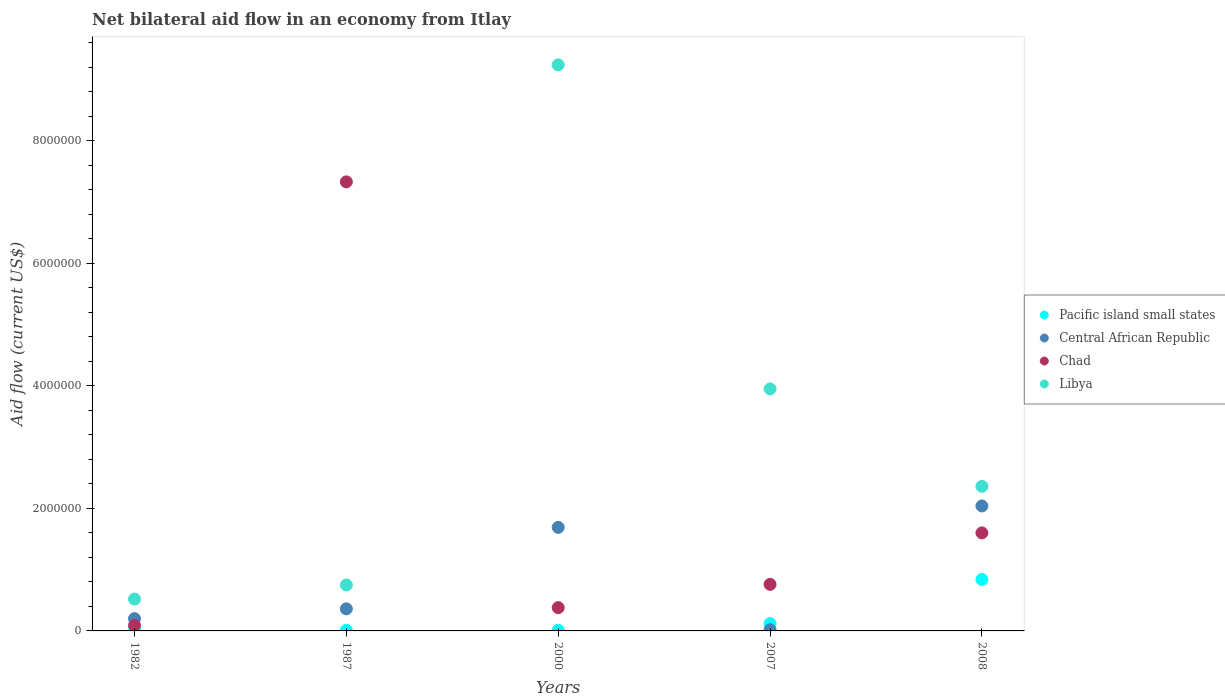Across all years, what is the maximum net bilateral aid flow in Pacific island small states?
Provide a short and direct response. 8.40e+05. In which year was the net bilateral aid flow in Central African Republic minimum?
Offer a terse response. 2007. What is the total net bilateral aid flow in Chad in the graph?
Keep it short and to the point. 1.02e+07. What is the difference between the net bilateral aid flow in Central African Republic in 1982 and that in 2000?
Your answer should be very brief. -1.49e+06. What is the average net bilateral aid flow in Chad per year?
Ensure brevity in your answer.  2.03e+06. In the year 2007, what is the difference between the net bilateral aid flow in Pacific island small states and net bilateral aid flow in Central African Republic?
Your response must be concise. 1.00e+05. What is the ratio of the net bilateral aid flow in Chad in 1982 to that in 2007?
Keep it short and to the point. 0.12. What is the difference between the highest and the second highest net bilateral aid flow in Pacific island small states?
Offer a terse response. 7.20e+05. What is the difference between the highest and the lowest net bilateral aid flow in Libya?
Your answer should be very brief. 8.72e+06. Is it the case that in every year, the sum of the net bilateral aid flow in Libya and net bilateral aid flow in Pacific island small states  is greater than the sum of net bilateral aid flow in Chad and net bilateral aid flow in Central African Republic?
Ensure brevity in your answer.  Yes. Is it the case that in every year, the sum of the net bilateral aid flow in Central African Republic and net bilateral aid flow in Chad  is greater than the net bilateral aid flow in Libya?
Provide a short and direct response. No. Is the net bilateral aid flow in Pacific island small states strictly less than the net bilateral aid flow in Libya over the years?
Offer a very short reply. Yes. Are the values on the major ticks of Y-axis written in scientific E-notation?
Your response must be concise. No. What is the title of the graph?
Make the answer very short. Net bilateral aid flow in an economy from Itlay. Does "Jamaica" appear as one of the legend labels in the graph?
Provide a succinct answer. No. What is the label or title of the X-axis?
Provide a short and direct response. Years. What is the Aid flow (current US$) in Libya in 1982?
Offer a very short reply. 5.20e+05. What is the Aid flow (current US$) of Central African Republic in 1987?
Keep it short and to the point. 3.60e+05. What is the Aid flow (current US$) of Chad in 1987?
Your answer should be compact. 7.33e+06. What is the Aid flow (current US$) of Libya in 1987?
Offer a very short reply. 7.50e+05. What is the Aid flow (current US$) in Pacific island small states in 2000?
Give a very brief answer. 10000. What is the Aid flow (current US$) of Central African Republic in 2000?
Make the answer very short. 1.69e+06. What is the Aid flow (current US$) in Libya in 2000?
Your response must be concise. 9.24e+06. What is the Aid flow (current US$) in Central African Republic in 2007?
Ensure brevity in your answer.  2.00e+04. What is the Aid flow (current US$) of Chad in 2007?
Your response must be concise. 7.60e+05. What is the Aid flow (current US$) in Libya in 2007?
Offer a very short reply. 3.95e+06. What is the Aid flow (current US$) in Pacific island small states in 2008?
Ensure brevity in your answer.  8.40e+05. What is the Aid flow (current US$) of Central African Republic in 2008?
Ensure brevity in your answer.  2.04e+06. What is the Aid flow (current US$) in Chad in 2008?
Your answer should be compact. 1.60e+06. What is the Aid flow (current US$) in Libya in 2008?
Make the answer very short. 2.36e+06. Across all years, what is the maximum Aid flow (current US$) in Pacific island small states?
Your answer should be compact. 8.40e+05. Across all years, what is the maximum Aid flow (current US$) of Central African Republic?
Offer a very short reply. 2.04e+06. Across all years, what is the maximum Aid flow (current US$) of Chad?
Keep it short and to the point. 7.33e+06. Across all years, what is the maximum Aid flow (current US$) of Libya?
Ensure brevity in your answer.  9.24e+06. Across all years, what is the minimum Aid flow (current US$) of Central African Republic?
Make the answer very short. 2.00e+04. Across all years, what is the minimum Aid flow (current US$) of Libya?
Provide a succinct answer. 5.20e+05. What is the total Aid flow (current US$) of Pacific island small states in the graph?
Provide a succinct answer. 1.02e+06. What is the total Aid flow (current US$) of Central African Republic in the graph?
Offer a very short reply. 4.31e+06. What is the total Aid flow (current US$) in Chad in the graph?
Your response must be concise. 1.02e+07. What is the total Aid flow (current US$) in Libya in the graph?
Ensure brevity in your answer.  1.68e+07. What is the difference between the Aid flow (current US$) of Pacific island small states in 1982 and that in 1987?
Offer a very short reply. 3.00e+04. What is the difference between the Aid flow (current US$) of Chad in 1982 and that in 1987?
Your response must be concise. -7.24e+06. What is the difference between the Aid flow (current US$) in Libya in 1982 and that in 1987?
Give a very brief answer. -2.30e+05. What is the difference between the Aid flow (current US$) of Central African Republic in 1982 and that in 2000?
Offer a very short reply. -1.49e+06. What is the difference between the Aid flow (current US$) of Chad in 1982 and that in 2000?
Ensure brevity in your answer.  -2.90e+05. What is the difference between the Aid flow (current US$) of Libya in 1982 and that in 2000?
Give a very brief answer. -8.72e+06. What is the difference between the Aid flow (current US$) in Pacific island small states in 1982 and that in 2007?
Offer a terse response. -8.00e+04. What is the difference between the Aid flow (current US$) in Central African Republic in 1982 and that in 2007?
Ensure brevity in your answer.  1.80e+05. What is the difference between the Aid flow (current US$) in Chad in 1982 and that in 2007?
Offer a terse response. -6.70e+05. What is the difference between the Aid flow (current US$) of Libya in 1982 and that in 2007?
Provide a short and direct response. -3.43e+06. What is the difference between the Aid flow (current US$) in Pacific island small states in 1982 and that in 2008?
Your response must be concise. -8.00e+05. What is the difference between the Aid flow (current US$) in Central African Republic in 1982 and that in 2008?
Your response must be concise. -1.84e+06. What is the difference between the Aid flow (current US$) of Chad in 1982 and that in 2008?
Keep it short and to the point. -1.51e+06. What is the difference between the Aid flow (current US$) in Libya in 1982 and that in 2008?
Your response must be concise. -1.84e+06. What is the difference between the Aid flow (current US$) of Pacific island small states in 1987 and that in 2000?
Offer a very short reply. 0. What is the difference between the Aid flow (current US$) in Central African Republic in 1987 and that in 2000?
Keep it short and to the point. -1.33e+06. What is the difference between the Aid flow (current US$) of Chad in 1987 and that in 2000?
Give a very brief answer. 6.95e+06. What is the difference between the Aid flow (current US$) in Libya in 1987 and that in 2000?
Make the answer very short. -8.49e+06. What is the difference between the Aid flow (current US$) of Central African Republic in 1987 and that in 2007?
Ensure brevity in your answer.  3.40e+05. What is the difference between the Aid flow (current US$) of Chad in 1987 and that in 2007?
Provide a succinct answer. 6.57e+06. What is the difference between the Aid flow (current US$) of Libya in 1987 and that in 2007?
Offer a very short reply. -3.20e+06. What is the difference between the Aid flow (current US$) in Pacific island small states in 1987 and that in 2008?
Provide a short and direct response. -8.30e+05. What is the difference between the Aid flow (current US$) of Central African Republic in 1987 and that in 2008?
Ensure brevity in your answer.  -1.68e+06. What is the difference between the Aid flow (current US$) of Chad in 1987 and that in 2008?
Your answer should be very brief. 5.73e+06. What is the difference between the Aid flow (current US$) of Libya in 1987 and that in 2008?
Make the answer very short. -1.61e+06. What is the difference between the Aid flow (current US$) of Central African Republic in 2000 and that in 2007?
Your answer should be compact. 1.67e+06. What is the difference between the Aid flow (current US$) of Chad in 2000 and that in 2007?
Provide a short and direct response. -3.80e+05. What is the difference between the Aid flow (current US$) of Libya in 2000 and that in 2007?
Provide a short and direct response. 5.29e+06. What is the difference between the Aid flow (current US$) in Pacific island small states in 2000 and that in 2008?
Provide a succinct answer. -8.30e+05. What is the difference between the Aid flow (current US$) in Central African Republic in 2000 and that in 2008?
Provide a succinct answer. -3.50e+05. What is the difference between the Aid flow (current US$) in Chad in 2000 and that in 2008?
Provide a succinct answer. -1.22e+06. What is the difference between the Aid flow (current US$) of Libya in 2000 and that in 2008?
Provide a short and direct response. 6.88e+06. What is the difference between the Aid flow (current US$) in Pacific island small states in 2007 and that in 2008?
Offer a very short reply. -7.20e+05. What is the difference between the Aid flow (current US$) in Central African Republic in 2007 and that in 2008?
Provide a succinct answer. -2.02e+06. What is the difference between the Aid flow (current US$) of Chad in 2007 and that in 2008?
Provide a short and direct response. -8.40e+05. What is the difference between the Aid flow (current US$) of Libya in 2007 and that in 2008?
Your response must be concise. 1.59e+06. What is the difference between the Aid flow (current US$) of Pacific island small states in 1982 and the Aid flow (current US$) of Central African Republic in 1987?
Offer a very short reply. -3.20e+05. What is the difference between the Aid flow (current US$) in Pacific island small states in 1982 and the Aid flow (current US$) in Chad in 1987?
Provide a short and direct response. -7.29e+06. What is the difference between the Aid flow (current US$) in Pacific island small states in 1982 and the Aid flow (current US$) in Libya in 1987?
Provide a succinct answer. -7.10e+05. What is the difference between the Aid flow (current US$) in Central African Republic in 1982 and the Aid flow (current US$) in Chad in 1987?
Provide a succinct answer. -7.13e+06. What is the difference between the Aid flow (current US$) in Central African Republic in 1982 and the Aid flow (current US$) in Libya in 1987?
Provide a succinct answer. -5.50e+05. What is the difference between the Aid flow (current US$) of Chad in 1982 and the Aid flow (current US$) of Libya in 1987?
Provide a succinct answer. -6.60e+05. What is the difference between the Aid flow (current US$) in Pacific island small states in 1982 and the Aid flow (current US$) in Central African Republic in 2000?
Offer a terse response. -1.65e+06. What is the difference between the Aid flow (current US$) in Pacific island small states in 1982 and the Aid flow (current US$) in Libya in 2000?
Your answer should be compact. -9.20e+06. What is the difference between the Aid flow (current US$) in Central African Republic in 1982 and the Aid flow (current US$) in Libya in 2000?
Your answer should be very brief. -9.04e+06. What is the difference between the Aid flow (current US$) of Chad in 1982 and the Aid flow (current US$) of Libya in 2000?
Provide a short and direct response. -9.15e+06. What is the difference between the Aid flow (current US$) in Pacific island small states in 1982 and the Aid flow (current US$) in Chad in 2007?
Offer a very short reply. -7.20e+05. What is the difference between the Aid flow (current US$) of Pacific island small states in 1982 and the Aid flow (current US$) of Libya in 2007?
Provide a short and direct response. -3.91e+06. What is the difference between the Aid flow (current US$) of Central African Republic in 1982 and the Aid flow (current US$) of Chad in 2007?
Ensure brevity in your answer.  -5.60e+05. What is the difference between the Aid flow (current US$) of Central African Republic in 1982 and the Aid flow (current US$) of Libya in 2007?
Offer a terse response. -3.75e+06. What is the difference between the Aid flow (current US$) of Chad in 1982 and the Aid flow (current US$) of Libya in 2007?
Offer a terse response. -3.86e+06. What is the difference between the Aid flow (current US$) in Pacific island small states in 1982 and the Aid flow (current US$) in Central African Republic in 2008?
Offer a terse response. -2.00e+06. What is the difference between the Aid flow (current US$) of Pacific island small states in 1982 and the Aid flow (current US$) of Chad in 2008?
Give a very brief answer. -1.56e+06. What is the difference between the Aid flow (current US$) in Pacific island small states in 1982 and the Aid flow (current US$) in Libya in 2008?
Keep it short and to the point. -2.32e+06. What is the difference between the Aid flow (current US$) of Central African Republic in 1982 and the Aid flow (current US$) of Chad in 2008?
Your answer should be very brief. -1.40e+06. What is the difference between the Aid flow (current US$) in Central African Republic in 1982 and the Aid flow (current US$) in Libya in 2008?
Your answer should be compact. -2.16e+06. What is the difference between the Aid flow (current US$) of Chad in 1982 and the Aid flow (current US$) of Libya in 2008?
Ensure brevity in your answer.  -2.27e+06. What is the difference between the Aid flow (current US$) of Pacific island small states in 1987 and the Aid flow (current US$) of Central African Republic in 2000?
Provide a succinct answer. -1.68e+06. What is the difference between the Aid flow (current US$) in Pacific island small states in 1987 and the Aid flow (current US$) in Chad in 2000?
Provide a succinct answer. -3.70e+05. What is the difference between the Aid flow (current US$) of Pacific island small states in 1987 and the Aid flow (current US$) of Libya in 2000?
Provide a short and direct response. -9.23e+06. What is the difference between the Aid flow (current US$) in Central African Republic in 1987 and the Aid flow (current US$) in Chad in 2000?
Offer a very short reply. -2.00e+04. What is the difference between the Aid flow (current US$) in Central African Republic in 1987 and the Aid flow (current US$) in Libya in 2000?
Your response must be concise. -8.88e+06. What is the difference between the Aid flow (current US$) in Chad in 1987 and the Aid flow (current US$) in Libya in 2000?
Provide a short and direct response. -1.91e+06. What is the difference between the Aid flow (current US$) in Pacific island small states in 1987 and the Aid flow (current US$) in Chad in 2007?
Keep it short and to the point. -7.50e+05. What is the difference between the Aid flow (current US$) in Pacific island small states in 1987 and the Aid flow (current US$) in Libya in 2007?
Your response must be concise. -3.94e+06. What is the difference between the Aid flow (current US$) of Central African Republic in 1987 and the Aid flow (current US$) of Chad in 2007?
Keep it short and to the point. -4.00e+05. What is the difference between the Aid flow (current US$) in Central African Republic in 1987 and the Aid flow (current US$) in Libya in 2007?
Make the answer very short. -3.59e+06. What is the difference between the Aid flow (current US$) of Chad in 1987 and the Aid flow (current US$) of Libya in 2007?
Ensure brevity in your answer.  3.38e+06. What is the difference between the Aid flow (current US$) of Pacific island small states in 1987 and the Aid flow (current US$) of Central African Republic in 2008?
Make the answer very short. -2.03e+06. What is the difference between the Aid flow (current US$) in Pacific island small states in 1987 and the Aid flow (current US$) in Chad in 2008?
Your answer should be compact. -1.59e+06. What is the difference between the Aid flow (current US$) in Pacific island small states in 1987 and the Aid flow (current US$) in Libya in 2008?
Provide a succinct answer. -2.35e+06. What is the difference between the Aid flow (current US$) in Central African Republic in 1987 and the Aid flow (current US$) in Chad in 2008?
Provide a short and direct response. -1.24e+06. What is the difference between the Aid flow (current US$) of Chad in 1987 and the Aid flow (current US$) of Libya in 2008?
Your response must be concise. 4.97e+06. What is the difference between the Aid flow (current US$) in Pacific island small states in 2000 and the Aid flow (current US$) in Chad in 2007?
Keep it short and to the point. -7.50e+05. What is the difference between the Aid flow (current US$) of Pacific island small states in 2000 and the Aid flow (current US$) of Libya in 2007?
Your response must be concise. -3.94e+06. What is the difference between the Aid flow (current US$) in Central African Republic in 2000 and the Aid flow (current US$) in Chad in 2007?
Give a very brief answer. 9.30e+05. What is the difference between the Aid flow (current US$) of Central African Republic in 2000 and the Aid flow (current US$) of Libya in 2007?
Offer a very short reply. -2.26e+06. What is the difference between the Aid flow (current US$) in Chad in 2000 and the Aid flow (current US$) in Libya in 2007?
Make the answer very short. -3.57e+06. What is the difference between the Aid flow (current US$) of Pacific island small states in 2000 and the Aid flow (current US$) of Central African Republic in 2008?
Your answer should be compact. -2.03e+06. What is the difference between the Aid flow (current US$) of Pacific island small states in 2000 and the Aid flow (current US$) of Chad in 2008?
Provide a short and direct response. -1.59e+06. What is the difference between the Aid flow (current US$) of Pacific island small states in 2000 and the Aid flow (current US$) of Libya in 2008?
Your answer should be compact. -2.35e+06. What is the difference between the Aid flow (current US$) in Central African Republic in 2000 and the Aid flow (current US$) in Chad in 2008?
Ensure brevity in your answer.  9.00e+04. What is the difference between the Aid flow (current US$) in Central African Republic in 2000 and the Aid flow (current US$) in Libya in 2008?
Your answer should be compact. -6.70e+05. What is the difference between the Aid flow (current US$) in Chad in 2000 and the Aid flow (current US$) in Libya in 2008?
Keep it short and to the point. -1.98e+06. What is the difference between the Aid flow (current US$) in Pacific island small states in 2007 and the Aid flow (current US$) in Central African Republic in 2008?
Provide a succinct answer. -1.92e+06. What is the difference between the Aid flow (current US$) in Pacific island small states in 2007 and the Aid flow (current US$) in Chad in 2008?
Your answer should be compact. -1.48e+06. What is the difference between the Aid flow (current US$) of Pacific island small states in 2007 and the Aid flow (current US$) of Libya in 2008?
Ensure brevity in your answer.  -2.24e+06. What is the difference between the Aid flow (current US$) in Central African Republic in 2007 and the Aid flow (current US$) in Chad in 2008?
Offer a very short reply. -1.58e+06. What is the difference between the Aid flow (current US$) of Central African Republic in 2007 and the Aid flow (current US$) of Libya in 2008?
Provide a succinct answer. -2.34e+06. What is the difference between the Aid flow (current US$) in Chad in 2007 and the Aid flow (current US$) in Libya in 2008?
Your answer should be very brief. -1.60e+06. What is the average Aid flow (current US$) in Pacific island small states per year?
Ensure brevity in your answer.  2.04e+05. What is the average Aid flow (current US$) in Central African Republic per year?
Ensure brevity in your answer.  8.62e+05. What is the average Aid flow (current US$) of Chad per year?
Your answer should be compact. 2.03e+06. What is the average Aid flow (current US$) in Libya per year?
Your answer should be very brief. 3.36e+06. In the year 1982, what is the difference between the Aid flow (current US$) of Pacific island small states and Aid flow (current US$) of Central African Republic?
Make the answer very short. -1.60e+05. In the year 1982, what is the difference between the Aid flow (current US$) in Pacific island small states and Aid flow (current US$) in Chad?
Your answer should be compact. -5.00e+04. In the year 1982, what is the difference between the Aid flow (current US$) in Pacific island small states and Aid flow (current US$) in Libya?
Ensure brevity in your answer.  -4.80e+05. In the year 1982, what is the difference between the Aid flow (current US$) in Central African Republic and Aid flow (current US$) in Libya?
Your answer should be very brief. -3.20e+05. In the year 1982, what is the difference between the Aid flow (current US$) in Chad and Aid flow (current US$) in Libya?
Provide a succinct answer. -4.30e+05. In the year 1987, what is the difference between the Aid flow (current US$) in Pacific island small states and Aid flow (current US$) in Central African Republic?
Your answer should be very brief. -3.50e+05. In the year 1987, what is the difference between the Aid flow (current US$) in Pacific island small states and Aid flow (current US$) in Chad?
Your response must be concise. -7.32e+06. In the year 1987, what is the difference between the Aid flow (current US$) in Pacific island small states and Aid flow (current US$) in Libya?
Your answer should be compact. -7.40e+05. In the year 1987, what is the difference between the Aid flow (current US$) in Central African Republic and Aid flow (current US$) in Chad?
Your answer should be very brief. -6.97e+06. In the year 1987, what is the difference between the Aid flow (current US$) in Central African Republic and Aid flow (current US$) in Libya?
Ensure brevity in your answer.  -3.90e+05. In the year 1987, what is the difference between the Aid flow (current US$) of Chad and Aid flow (current US$) of Libya?
Your response must be concise. 6.58e+06. In the year 2000, what is the difference between the Aid flow (current US$) of Pacific island small states and Aid flow (current US$) of Central African Republic?
Your response must be concise. -1.68e+06. In the year 2000, what is the difference between the Aid flow (current US$) in Pacific island small states and Aid flow (current US$) in Chad?
Your answer should be very brief. -3.70e+05. In the year 2000, what is the difference between the Aid flow (current US$) in Pacific island small states and Aid flow (current US$) in Libya?
Your answer should be very brief. -9.23e+06. In the year 2000, what is the difference between the Aid flow (current US$) of Central African Republic and Aid flow (current US$) of Chad?
Make the answer very short. 1.31e+06. In the year 2000, what is the difference between the Aid flow (current US$) of Central African Republic and Aid flow (current US$) of Libya?
Your answer should be very brief. -7.55e+06. In the year 2000, what is the difference between the Aid flow (current US$) in Chad and Aid flow (current US$) in Libya?
Offer a very short reply. -8.86e+06. In the year 2007, what is the difference between the Aid flow (current US$) in Pacific island small states and Aid flow (current US$) in Central African Republic?
Provide a succinct answer. 1.00e+05. In the year 2007, what is the difference between the Aid flow (current US$) in Pacific island small states and Aid flow (current US$) in Chad?
Keep it short and to the point. -6.40e+05. In the year 2007, what is the difference between the Aid flow (current US$) in Pacific island small states and Aid flow (current US$) in Libya?
Your response must be concise. -3.83e+06. In the year 2007, what is the difference between the Aid flow (current US$) in Central African Republic and Aid flow (current US$) in Chad?
Offer a terse response. -7.40e+05. In the year 2007, what is the difference between the Aid flow (current US$) in Central African Republic and Aid flow (current US$) in Libya?
Your answer should be very brief. -3.93e+06. In the year 2007, what is the difference between the Aid flow (current US$) in Chad and Aid flow (current US$) in Libya?
Your answer should be very brief. -3.19e+06. In the year 2008, what is the difference between the Aid flow (current US$) in Pacific island small states and Aid flow (current US$) in Central African Republic?
Your answer should be compact. -1.20e+06. In the year 2008, what is the difference between the Aid flow (current US$) in Pacific island small states and Aid flow (current US$) in Chad?
Provide a short and direct response. -7.60e+05. In the year 2008, what is the difference between the Aid flow (current US$) of Pacific island small states and Aid flow (current US$) of Libya?
Provide a short and direct response. -1.52e+06. In the year 2008, what is the difference between the Aid flow (current US$) in Central African Republic and Aid flow (current US$) in Chad?
Your answer should be very brief. 4.40e+05. In the year 2008, what is the difference between the Aid flow (current US$) in Central African Republic and Aid flow (current US$) in Libya?
Give a very brief answer. -3.20e+05. In the year 2008, what is the difference between the Aid flow (current US$) of Chad and Aid flow (current US$) of Libya?
Give a very brief answer. -7.60e+05. What is the ratio of the Aid flow (current US$) in Central African Republic in 1982 to that in 1987?
Your answer should be compact. 0.56. What is the ratio of the Aid flow (current US$) in Chad in 1982 to that in 1987?
Your answer should be compact. 0.01. What is the ratio of the Aid flow (current US$) of Libya in 1982 to that in 1987?
Your response must be concise. 0.69. What is the ratio of the Aid flow (current US$) in Pacific island small states in 1982 to that in 2000?
Keep it short and to the point. 4. What is the ratio of the Aid flow (current US$) of Central African Republic in 1982 to that in 2000?
Give a very brief answer. 0.12. What is the ratio of the Aid flow (current US$) in Chad in 1982 to that in 2000?
Offer a very short reply. 0.24. What is the ratio of the Aid flow (current US$) in Libya in 1982 to that in 2000?
Your answer should be very brief. 0.06. What is the ratio of the Aid flow (current US$) of Pacific island small states in 1982 to that in 2007?
Your answer should be very brief. 0.33. What is the ratio of the Aid flow (current US$) in Chad in 1982 to that in 2007?
Give a very brief answer. 0.12. What is the ratio of the Aid flow (current US$) in Libya in 1982 to that in 2007?
Give a very brief answer. 0.13. What is the ratio of the Aid flow (current US$) of Pacific island small states in 1982 to that in 2008?
Your answer should be very brief. 0.05. What is the ratio of the Aid flow (current US$) in Central African Republic in 1982 to that in 2008?
Make the answer very short. 0.1. What is the ratio of the Aid flow (current US$) of Chad in 1982 to that in 2008?
Offer a terse response. 0.06. What is the ratio of the Aid flow (current US$) in Libya in 1982 to that in 2008?
Your answer should be compact. 0.22. What is the ratio of the Aid flow (current US$) in Pacific island small states in 1987 to that in 2000?
Give a very brief answer. 1. What is the ratio of the Aid flow (current US$) in Central African Republic in 1987 to that in 2000?
Provide a short and direct response. 0.21. What is the ratio of the Aid flow (current US$) of Chad in 1987 to that in 2000?
Your answer should be compact. 19.29. What is the ratio of the Aid flow (current US$) of Libya in 1987 to that in 2000?
Provide a short and direct response. 0.08. What is the ratio of the Aid flow (current US$) of Pacific island small states in 1987 to that in 2007?
Ensure brevity in your answer.  0.08. What is the ratio of the Aid flow (current US$) of Central African Republic in 1987 to that in 2007?
Offer a very short reply. 18. What is the ratio of the Aid flow (current US$) in Chad in 1987 to that in 2007?
Offer a terse response. 9.64. What is the ratio of the Aid flow (current US$) in Libya in 1987 to that in 2007?
Provide a short and direct response. 0.19. What is the ratio of the Aid flow (current US$) of Pacific island small states in 1987 to that in 2008?
Keep it short and to the point. 0.01. What is the ratio of the Aid flow (current US$) in Central African Republic in 1987 to that in 2008?
Make the answer very short. 0.18. What is the ratio of the Aid flow (current US$) in Chad in 1987 to that in 2008?
Your response must be concise. 4.58. What is the ratio of the Aid flow (current US$) of Libya in 1987 to that in 2008?
Your answer should be very brief. 0.32. What is the ratio of the Aid flow (current US$) of Pacific island small states in 2000 to that in 2007?
Provide a short and direct response. 0.08. What is the ratio of the Aid flow (current US$) of Central African Republic in 2000 to that in 2007?
Offer a very short reply. 84.5. What is the ratio of the Aid flow (current US$) in Chad in 2000 to that in 2007?
Provide a succinct answer. 0.5. What is the ratio of the Aid flow (current US$) in Libya in 2000 to that in 2007?
Your answer should be compact. 2.34. What is the ratio of the Aid flow (current US$) of Pacific island small states in 2000 to that in 2008?
Ensure brevity in your answer.  0.01. What is the ratio of the Aid flow (current US$) in Central African Republic in 2000 to that in 2008?
Ensure brevity in your answer.  0.83. What is the ratio of the Aid flow (current US$) in Chad in 2000 to that in 2008?
Make the answer very short. 0.24. What is the ratio of the Aid flow (current US$) in Libya in 2000 to that in 2008?
Make the answer very short. 3.92. What is the ratio of the Aid flow (current US$) of Pacific island small states in 2007 to that in 2008?
Keep it short and to the point. 0.14. What is the ratio of the Aid flow (current US$) of Central African Republic in 2007 to that in 2008?
Keep it short and to the point. 0.01. What is the ratio of the Aid flow (current US$) of Chad in 2007 to that in 2008?
Offer a very short reply. 0.47. What is the ratio of the Aid flow (current US$) of Libya in 2007 to that in 2008?
Your answer should be compact. 1.67. What is the difference between the highest and the second highest Aid flow (current US$) in Pacific island small states?
Keep it short and to the point. 7.20e+05. What is the difference between the highest and the second highest Aid flow (current US$) of Chad?
Provide a short and direct response. 5.73e+06. What is the difference between the highest and the second highest Aid flow (current US$) of Libya?
Provide a short and direct response. 5.29e+06. What is the difference between the highest and the lowest Aid flow (current US$) of Pacific island small states?
Give a very brief answer. 8.30e+05. What is the difference between the highest and the lowest Aid flow (current US$) of Central African Republic?
Your response must be concise. 2.02e+06. What is the difference between the highest and the lowest Aid flow (current US$) in Chad?
Your answer should be very brief. 7.24e+06. What is the difference between the highest and the lowest Aid flow (current US$) in Libya?
Your answer should be very brief. 8.72e+06. 